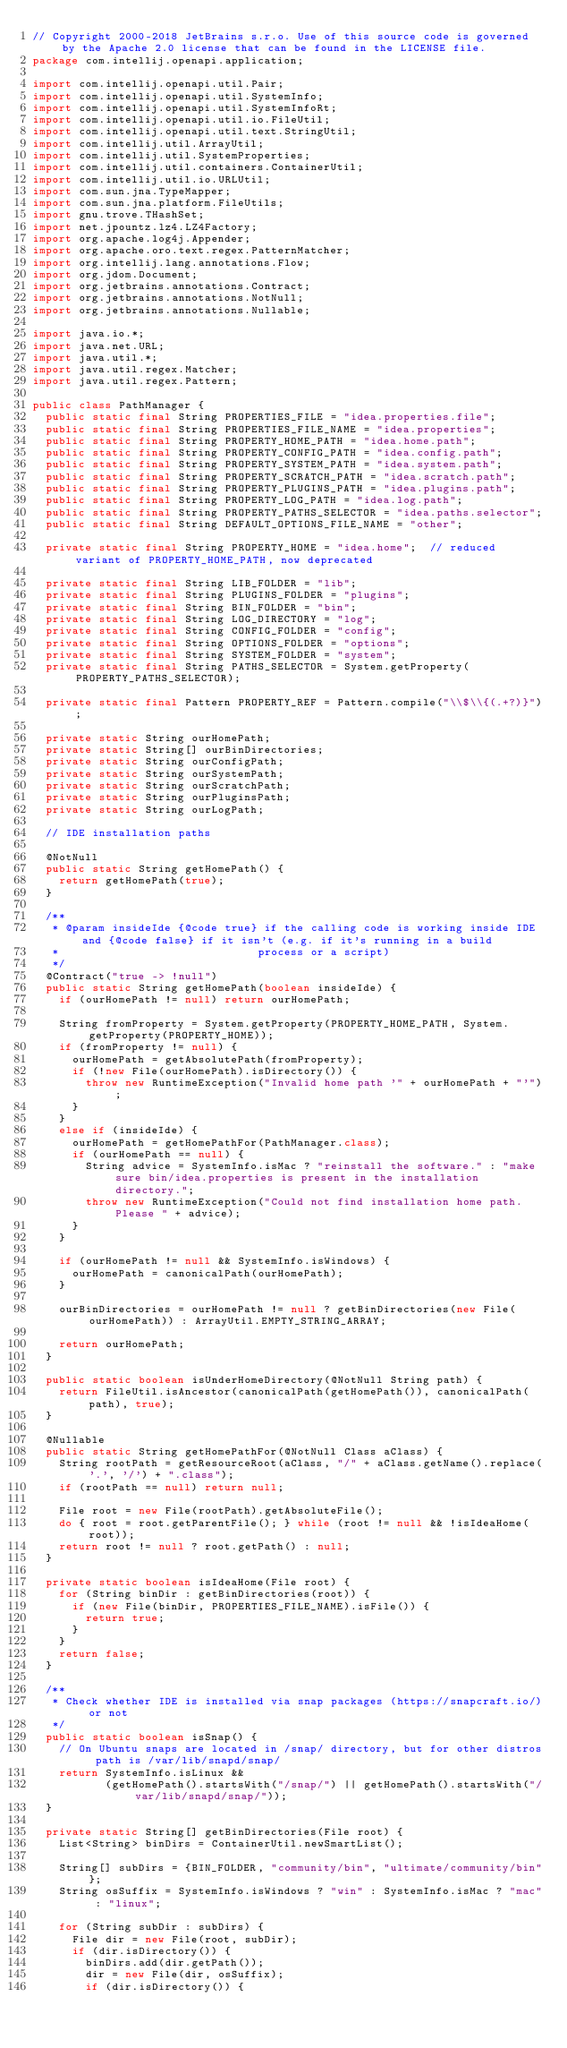Convert code to text. <code><loc_0><loc_0><loc_500><loc_500><_Java_>// Copyright 2000-2018 JetBrains s.r.o. Use of this source code is governed by the Apache 2.0 license that can be found in the LICENSE file.
package com.intellij.openapi.application;

import com.intellij.openapi.util.Pair;
import com.intellij.openapi.util.SystemInfo;
import com.intellij.openapi.util.SystemInfoRt;
import com.intellij.openapi.util.io.FileUtil;
import com.intellij.openapi.util.text.StringUtil;
import com.intellij.util.ArrayUtil;
import com.intellij.util.SystemProperties;
import com.intellij.util.containers.ContainerUtil;
import com.intellij.util.io.URLUtil;
import com.sun.jna.TypeMapper;
import com.sun.jna.platform.FileUtils;
import gnu.trove.THashSet;
import net.jpountz.lz4.LZ4Factory;
import org.apache.log4j.Appender;
import org.apache.oro.text.regex.PatternMatcher;
import org.intellij.lang.annotations.Flow;
import org.jdom.Document;
import org.jetbrains.annotations.Contract;
import org.jetbrains.annotations.NotNull;
import org.jetbrains.annotations.Nullable;

import java.io.*;
import java.net.URL;
import java.util.*;
import java.util.regex.Matcher;
import java.util.regex.Pattern;

public class PathManager {
  public static final String PROPERTIES_FILE = "idea.properties.file";
  public static final String PROPERTIES_FILE_NAME = "idea.properties";
  public static final String PROPERTY_HOME_PATH = "idea.home.path";
  public static final String PROPERTY_CONFIG_PATH = "idea.config.path";
  public static final String PROPERTY_SYSTEM_PATH = "idea.system.path";
  public static final String PROPERTY_SCRATCH_PATH = "idea.scratch.path";
  public static final String PROPERTY_PLUGINS_PATH = "idea.plugins.path";
  public static final String PROPERTY_LOG_PATH = "idea.log.path";
  public static final String PROPERTY_PATHS_SELECTOR = "idea.paths.selector";
  public static final String DEFAULT_OPTIONS_FILE_NAME = "other";

  private static final String PROPERTY_HOME = "idea.home";  // reduced variant of PROPERTY_HOME_PATH, now deprecated

  private static final String LIB_FOLDER = "lib";
  private static final String PLUGINS_FOLDER = "plugins";
  private static final String BIN_FOLDER = "bin";
  private static final String LOG_DIRECTORY = "log";
  private static final String CONFIG_FOLDER = "config";
  private static final String OPTIONS_FOLDER = "options";
  private static final String SYSTEM_FOLDER = "system";
  private static final String PATHS_SELECTOR = System.getProperty(PROPERTY_PATHS_SELECTOR);

  private static final Pattern PROPERTY_REF = Pattern.compile("\\$\\{(.+?)}");

  private static String ourHomePath;
  private static String[] ourBinDirectories;
  private static String ourConfigPath;
  private static String ourSystemPath;
  private static String ourScratchPath;
  private static String ourPluginsPath;
  private static String ourLogPath;

  // IDE installation paths

  @NotNull
  public static String getHomePath() {
    return getHomePath(true);
  }

  /**
   * @param insideIde {@code true} if the calling code is working inside IDE and {@code false} if it isn't (e.g. if it's running in a build
   *                              process or a script)
   */
  @Contract("true -> !null")
  public static String getHomePath(boolean insideIde) {
    if (ourHomePath != null) return ourHomePath;

    String fromProperty = System.getProperty(PROPERTY_HOME_PATH, System.getProperty(PROPERTY_HOME));
    if (fromProperty != null) {
      ourHomePath = getAbsolutePath(fromProperty);
      if (!new File(ourHomePath).isDirectory()) {
        throw new RuntimeException("Invalid home path '" + ourHomePath + "'");
      }
    }
    else if (insideIde) {
      ourHomePath = getHomePathFor(PathManager.class);
      if (ourHomePath == null) {
        String advice = SystemInfo.isMac ? "reinstall the software." : "make sure bin/idea.properties is present in the installation directory.";
        throw new RuntimeException("Could not find installation home path. Please " + advice);
      }
    }

    if (ourHomePath != null && SystemInfo.isWindows) {
      ourHomePath = canonicalPath(ourHomePath);
    }

    ourBinDirectories = ourHomePath != null ? getBinDirectories(new File(ourHomePath)) : ArrayUtil.EMPTY_STRING_ARRAY;

    return ourHomePath;
  }

  public static boolean isUnderHomeDirectory(@NotNull String path) {
    return FileUtil.isAncestor(canonicalPath(getHomePath()), canonicalPath(path), true);
  }

  @Nullable
  public static String getHomePathFor(@NotNull Class aClass) {
    String rootPath = getResourceRoot(aClass, "/" + aClass.getName().replace('.', '/') + ".class");
    if (rootPath == null) return null;

    File root = new File(rootPath).getAbsoluteFile();
    do { root = root.getParentFile(); } while (root != null && !isIdeaHome(root));
    return root != null ? root.getPath() : null;
  }

  private static boolean isIdeaHome(File root) {
    for (String binDir : getBinDirectories(root)) {
      if (new File(binDir, PROPERTIES_FILE_NAME).isFile()) {
        return true;
      }
    }
    return false;
  }

  /**
   * Check whether IDE is installed via snap packages (https://snapcraft.io/) or not
   */
  public static boolean isSnap() {
    // On Ubuntu snaps are located in /snap/ directory, but for other distros path is /var/lib/snapd/snap/
    return SystemInfo.isLinux &&
           (getHomePath().startsWith("/snap/") || getHomePath().startsWith("/var/lib/snapd/snap/"));
  }

  private static String[] getBinDirectories(File root) {
    List<String> binDirs = ContainerUtil.newSmartList();

    String[] subDirs = {BIN_FOLDER, "community/bin", "ultimate/community/bin"};
    String osSuffix = SystemInfo.isWindows ? "win" : SystemInfo.isMac ? "mac" : "linux";

    for (String subDir : subDirs) {
      File dir = new File(root, subDir);
      if (dir.isDirectory()) {
        binDirs.add(dir.getPath());
        dir = new File(dir, osSuffix);
        if (dir.isDirectory()) {</code> 